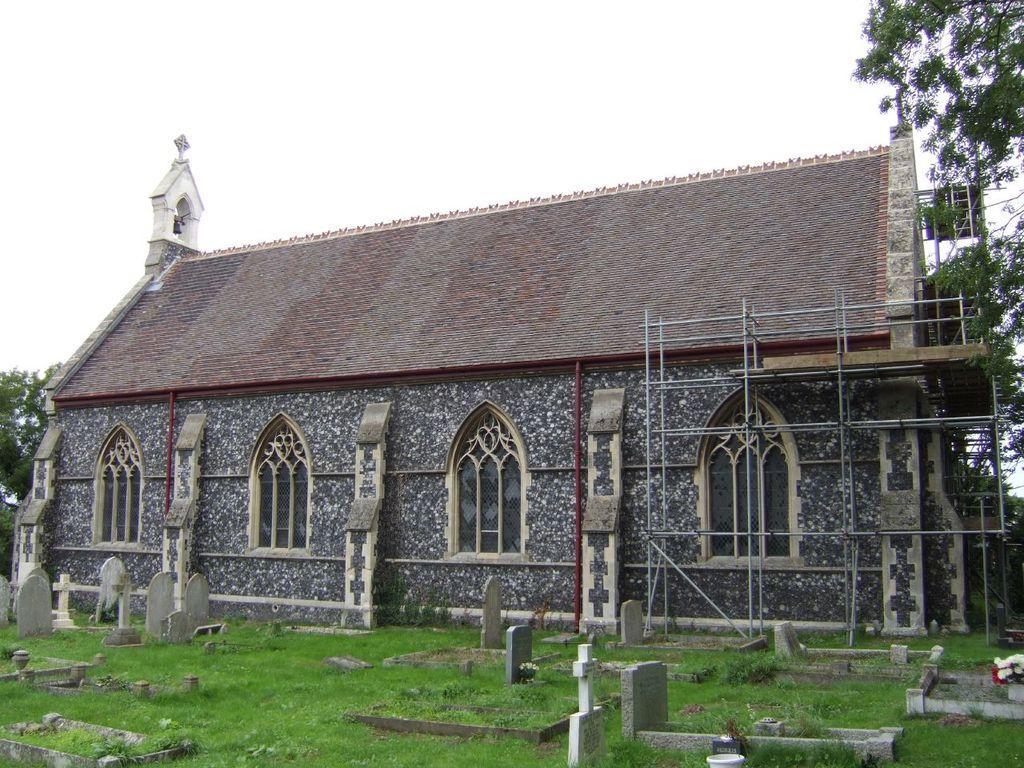In one or two sentences, can you explain what this image depicts? Here in this picture we can see graves present on the ground over there and we can see grass covered all over there and in the middle we can see church building present and on that we can see windows present over there and we can see trees present all over there. 